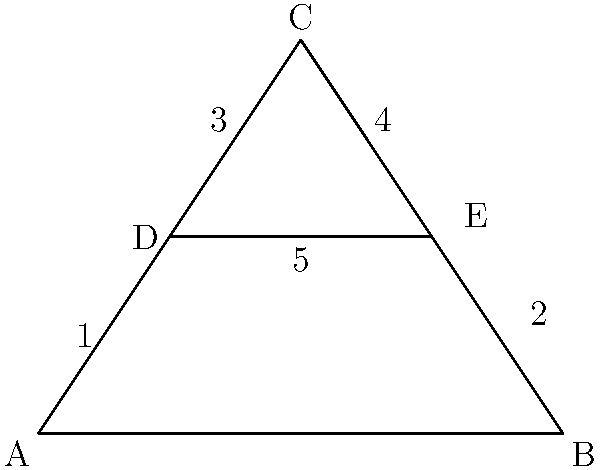As a historical architecture enthusiast from Derbyshire, you're likely familiar with Gothic arches. Identify the components of this simplified Gothic arch diagram by matching the numbers (1-5) to their correct architectural terms: Springing line, Voussoirs, Apex, Intrados, and Extrados. Let's break down the components of a Gothic arch step-by-step:

1. The springing line (1 and 2) is the horizontal line from which the arch rises. It's represented by the base of the arch, connecting points A and B.

2. Voussoirs (3 and 4) are the wedge-shaped stones that make up the arch. They're represented by the sloping sides of the arch from points D and E to point C.

3. The apex (C) is the highest point of the arch, where the two sides meet.

4. The intrados (5) is the inner curve of the arch, represented by the line connecting points D and E.

5. The extrados is the outer curve of the arch, represented by the lines connecting points A to C and B to C.

Matching the numbers to the terms:
1 and 2: Springing line
3 and 4: Voussoirs
C: Apex
5: Intrados
A-C-B: Extrados
Answer: 1,2: Springing line; 3,4: Voussoirs; C: Apex; 5: Intrados; A-C-B: Extrados 